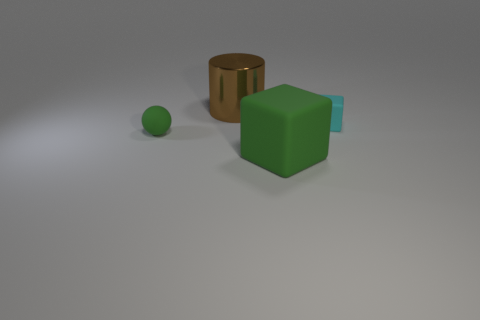Add 3 brown metallic cylinders. How many objects exist? 7 Subtract all cylinders. How many objects are left? 3 Add 2 green matte things. How many green matte things exist? 4 Subtract 0 yellow balls. How many objects are left? 4 Subtract all green spheres. Subtract all small gray balls. How many objects are left? 3 Add 2 tiny cyan things. How many tiny cyan things are left? 3 